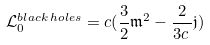Convert formula to latex. <formula><loc_0><loc_0><loc_500><loc_500>\mathcal { L } ^ { b l a c k \, h o l e s } _ { 0 } = c ( \frac { 3 } { 2 } \mathfrak m ^ { 2 } - \frac { 2 } { 3 c \, } \mathfrak j )</formula> 